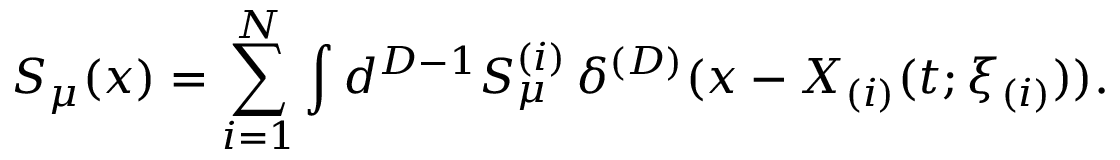<formula> <loc_0><loc_0><loc_500><loc_500>S _ { \mu } ( x ) = \sum _ { i = 1 } ^ { N } \int d ^ { D - 1 } S _ { \mu } ^ { ( i ) } \, \delta ^ { ( D ) } ( x - X _ { ( i ) } ( t ; \xi _ { ( i ) } ) ) .</formula> 